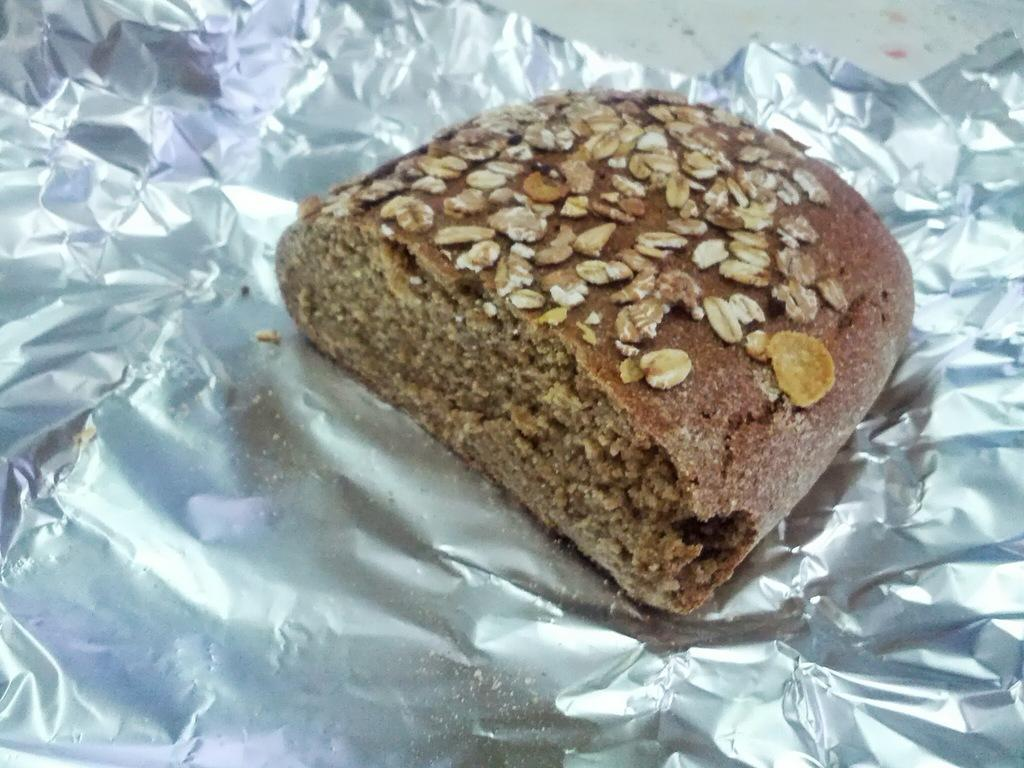What is the main subject of the image? The main subject of the image is a bread. How is the bread being stored or wrapped in the image? The bread is kept in a silver foil. What type of nose can be seen on the bread in the image? There is no nose present on the bread in the image. Is the bread located in a hall in the image? The provided facts do not mention a hall, so it cannot be determined from the image. Can you see the moon in the image? The provided facts do not mention the moon, so it cannot be determined from the image. 